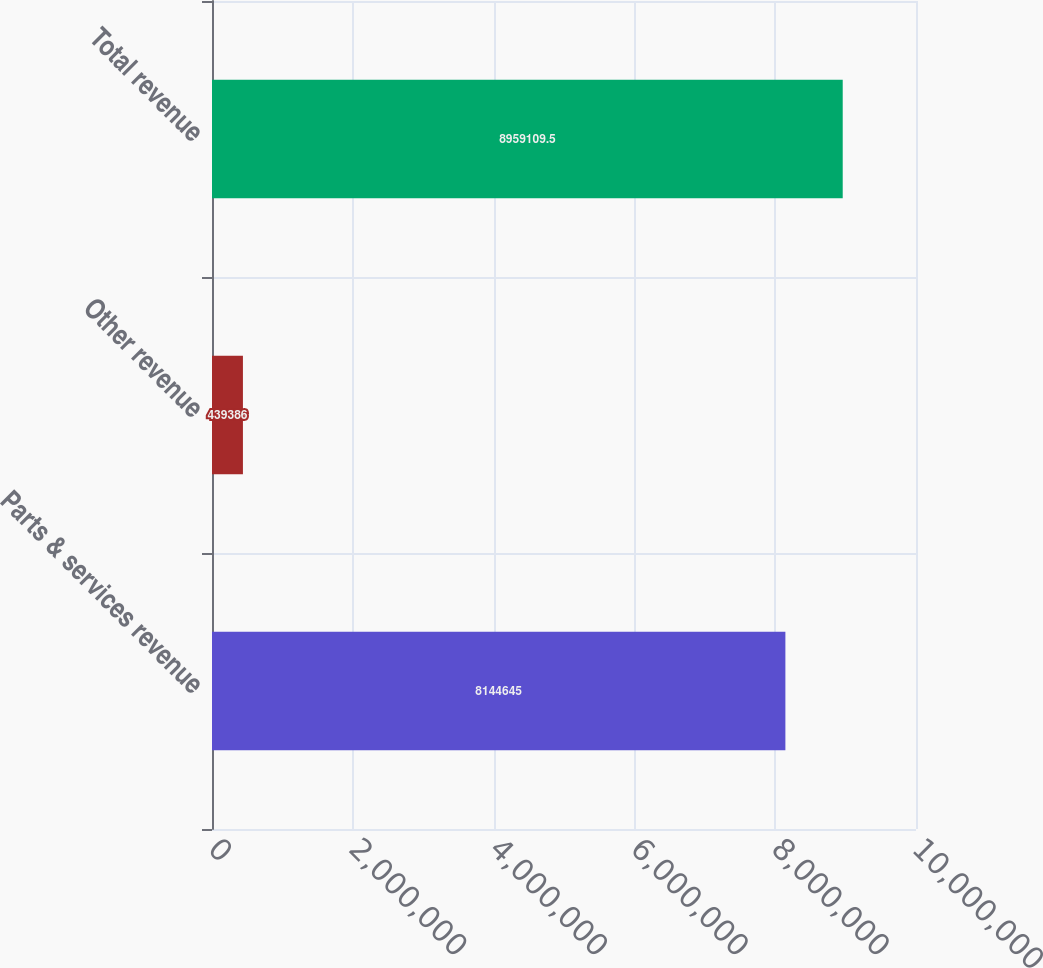Convert chart to OTSL. <chart><loc_0><loc_0><loc_500><loc_500><bar_chart><fcel>Parts & services revenue<fcel>Other revenue<fcel>Total revenue<nl><fcel>8.14464e+06<fcel>439386<fcel>8.95911e+06<nl></chart> 